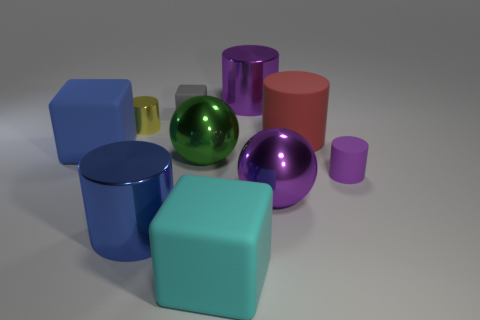Subtract all large blocks. How many blocks are left? 1 Subtract 1 cylinders. How many cylinders are left? 4 Add 7 blue metallic cylinders. How many blue metallic cylinders exist? 8 Subtract all green balls. How many balls are left? 1 Subtract 0 brown cylinders. How many objects are left? 10 Subtract all balls. How many objects are left? 8 Subtract all green cylinders. Subtract all yellow balls. How many cylinders are left? 5 Subtract all cyan cylinders. How many yellow blocks are left? 0 Subtract all cyan rubber cubes. Subtract all purple cylinders. How many objects are left? 7 Add 1 big purple balls. How many big purple balls are left? 2 